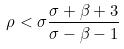Convert formula to latex. <formula><loc_0><loc_0><loc_500><loc_500>\rho < \sigma \frac { \sigma + \beta + 3 } { \sigma - \beta - 1 }</formula> 